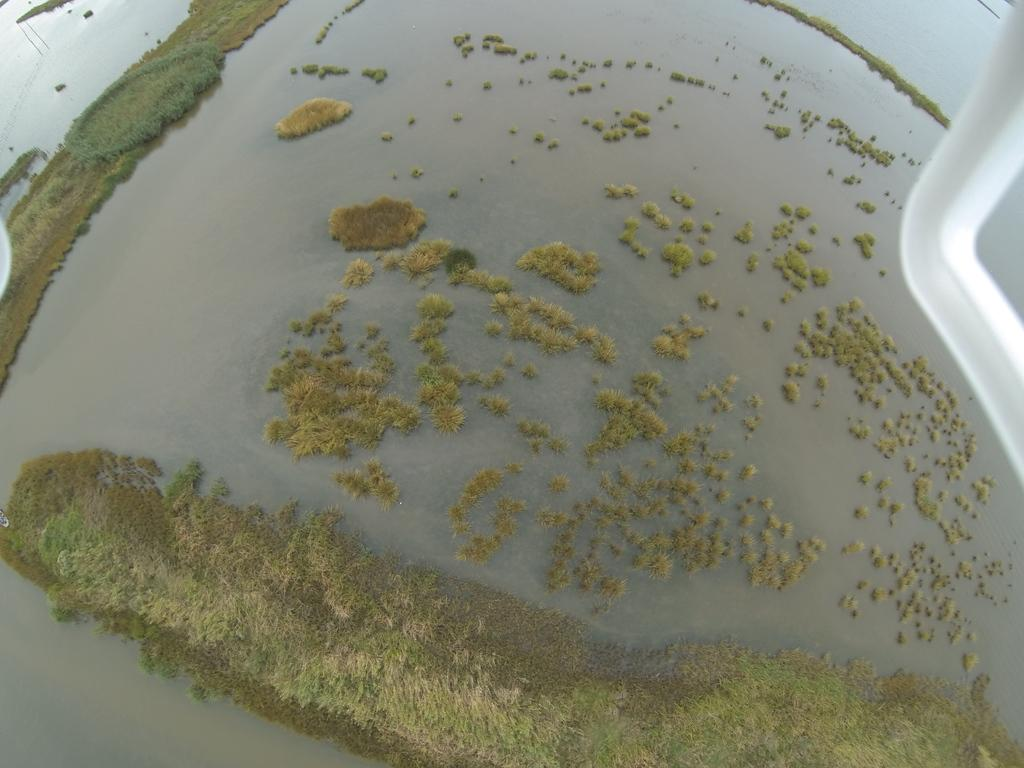What is the perspective of the image? The image appears to be taken from an airplane. What object can be seen on the right side of the image? There is a metal rod on the right side of the image. What type of vegetation is visible in the background of the image? There is grass visible in the background of the image. What natural feature can be seen in the background of the image? There is water visible in the background of the image. What type of poison is being used to treat the grass in the image? There is no indication of any poison being used in the image; the grass appears to be natural. 